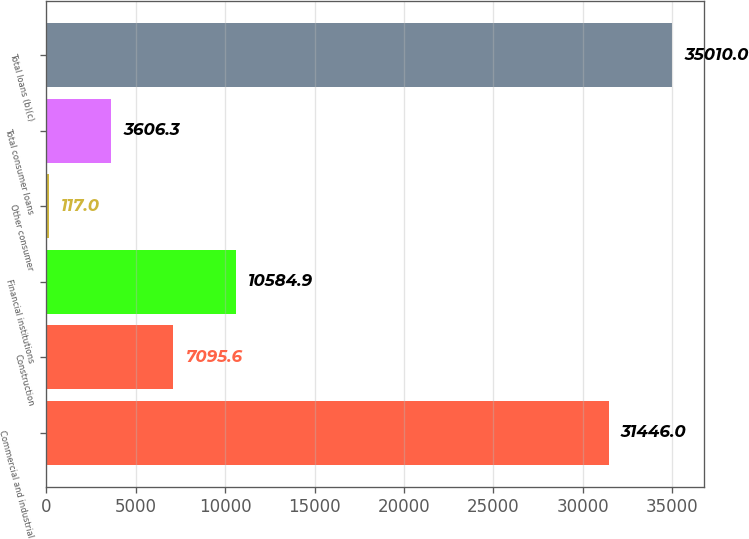Convert chart. <chart><loc_0><loc_0><loc_500><loc_500><bar_chart><fcel>Commercial and industrial<fcel>Construction<fcel>Financial institutions<fcel>Other consumer<fcel>Total consumer loans<fcel>Total loans (b)(c)<nl><fcel>31446<fcel>7095.6<fcel>10584.9<fcel>117<fcel>3606.3<fcel>35010<nl></chart> 